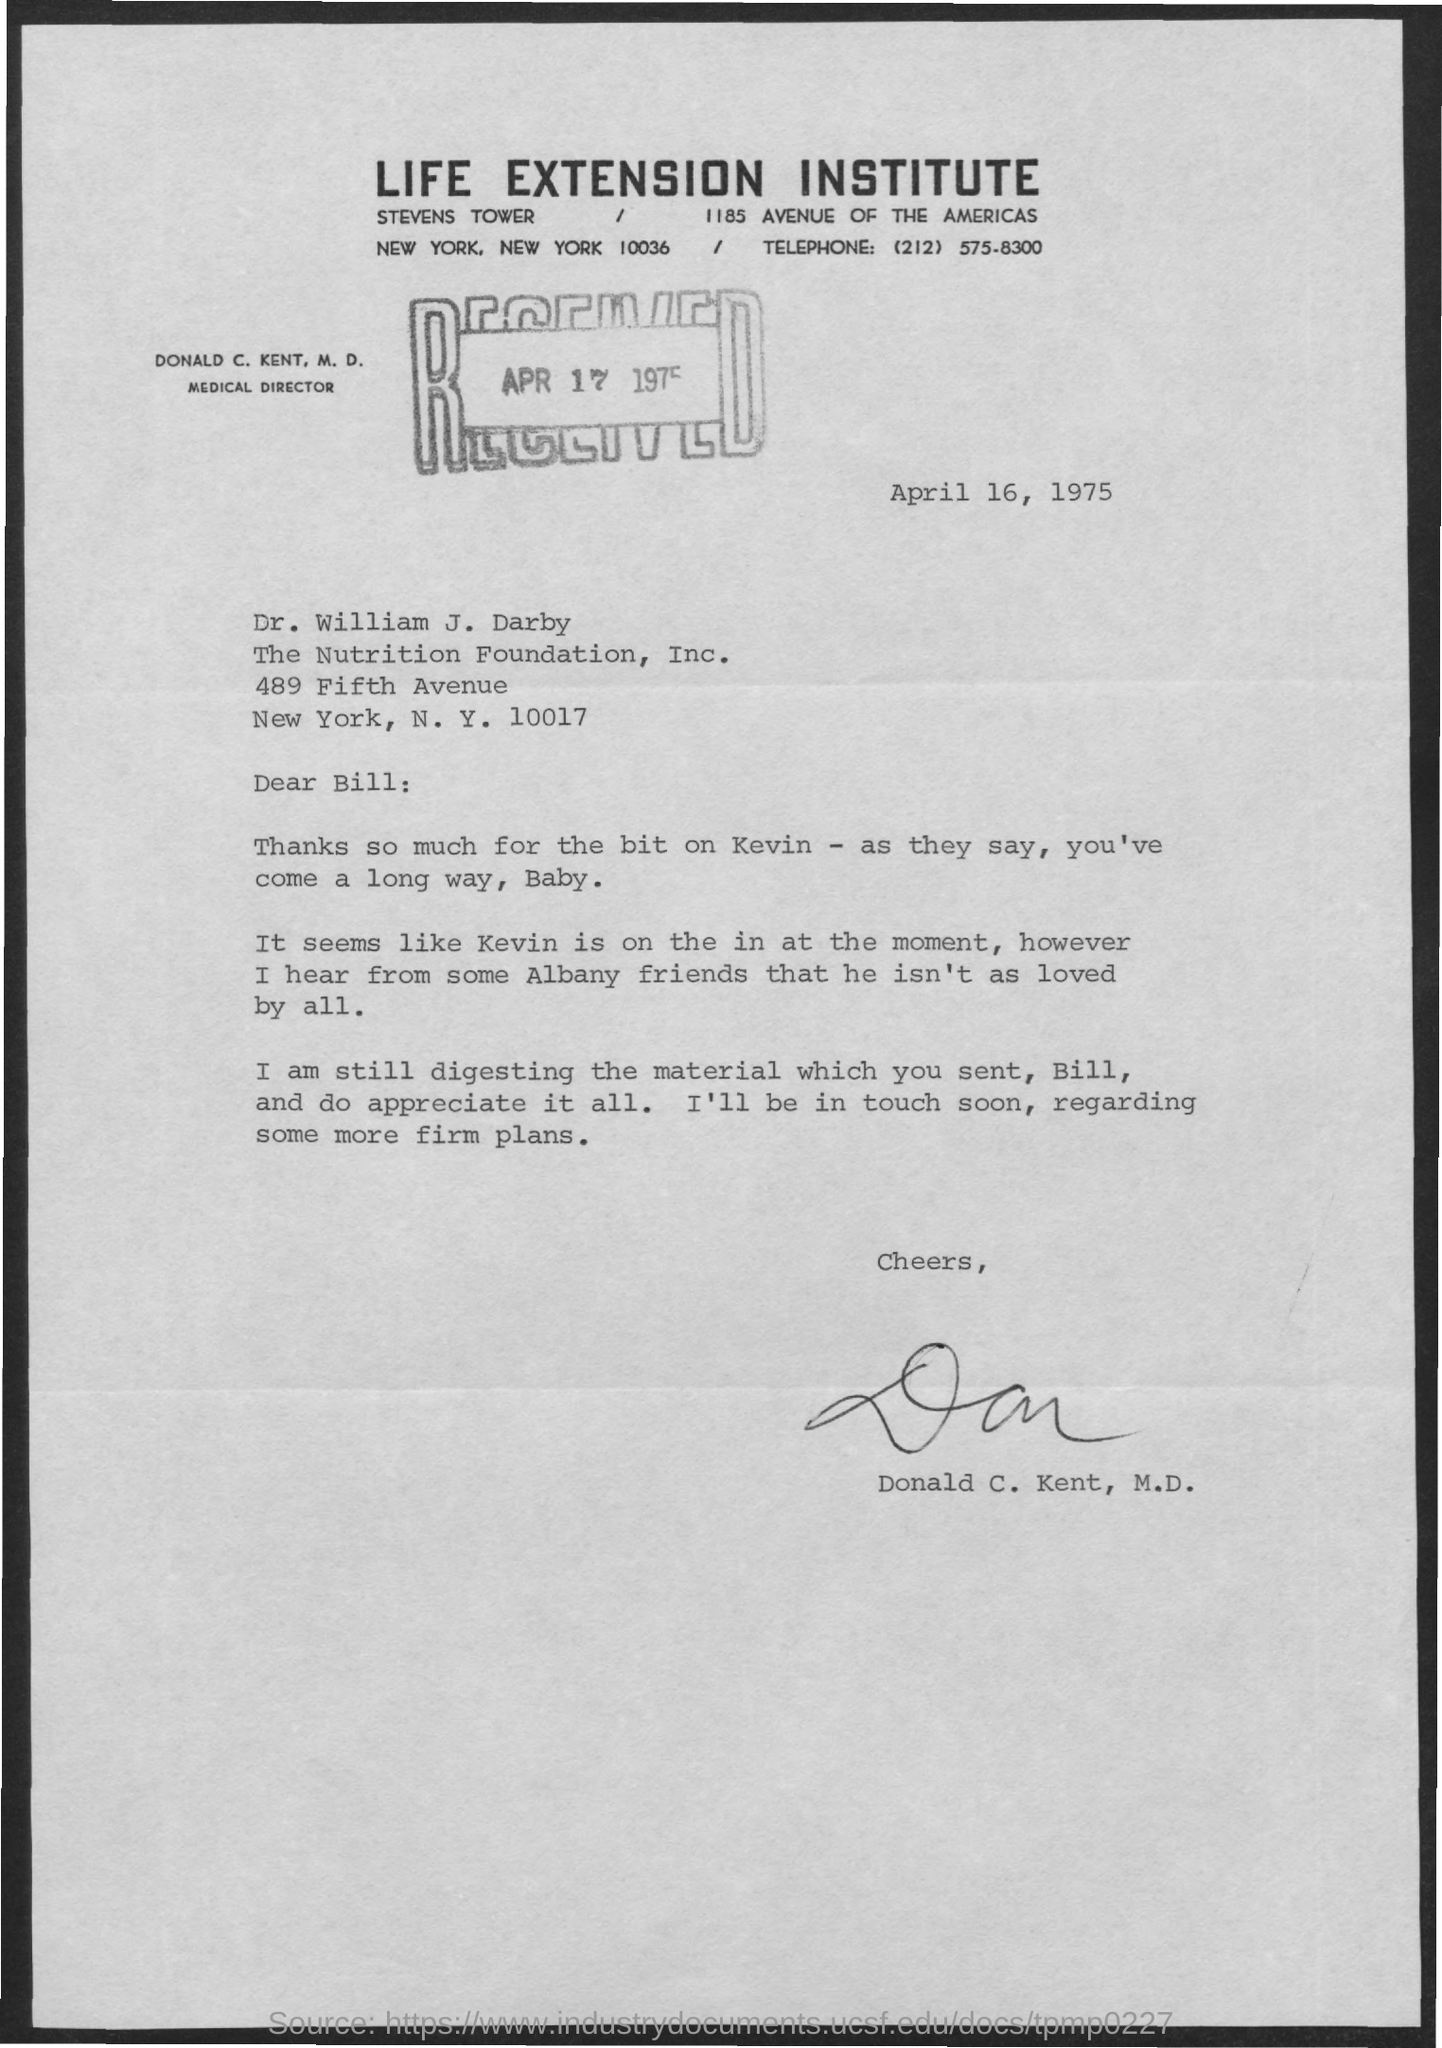Outline some significant characteristics in this image. The letter is addressed to Bill. The sender is Donald C. Kent. Dr. Donald C. Kent is the Medical Director. The document is dated April 16, 1975. On April 17, 1975, the letter was received. 